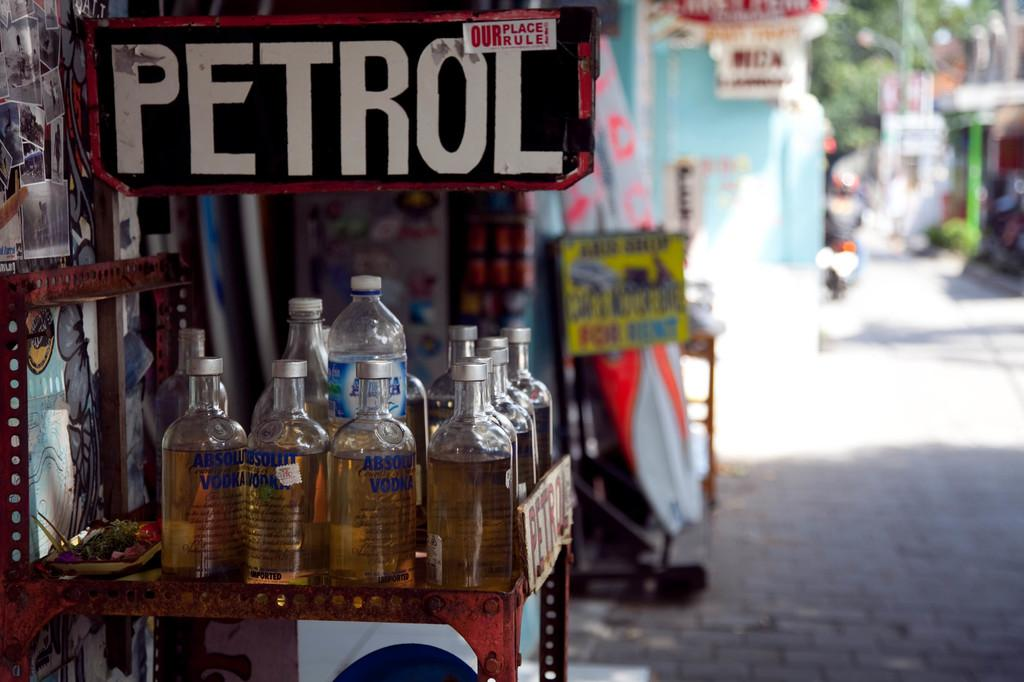<image>
Offer a succinct explanation of the picture presented. Several bottles of Absolute Vodka are on a table under a sign that reads PETROL. 